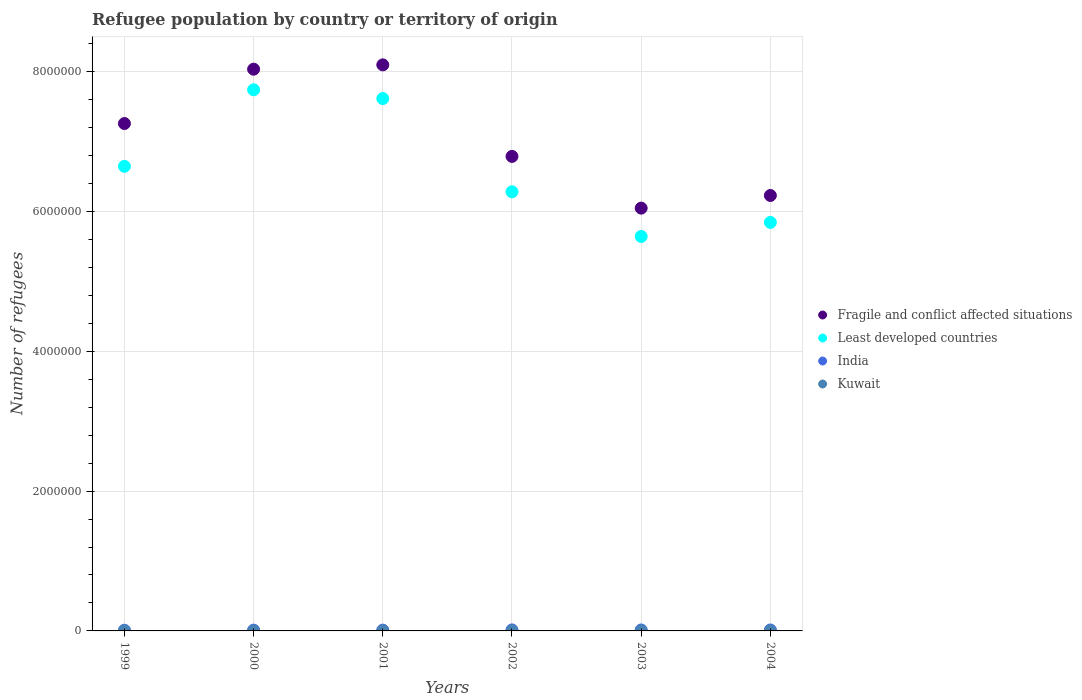How many different coloured dotlines are there?
Offer a terse response. 4. What is the number of refugees in Least developed countries in 2000?
Your answer should be compact. 7.74e+06. Across all years, what is the maximum number of refugees in Fragile and conflict affected situations?
Ensure brevity in your answer.  8.10e+06. Across all years, what is the minimum number of refugees in India?
Your answer should be very brief. 9845. In which year was the number of refugees in India maximum?
Give a very brief answer. 2002. In which year was the number of refugees in Fragile and conflict affected situations minimum?
Your answer should be compact. 2003. What is the total number of refugees in Least developed countries in the graph?
Your response must be concise. 3.98e+07. What is the difference between the number of refugees in India in 1999 and that in 2003?
Make the answer very short. -3861. What is the difference between the number of refugees in Kuwait in 2002 and the number of refugees in Fragile and conflict affected situations in 2003?
Give a very brief answer. -6.05e+06. What is the average number of refugees in Least developed countries per year?
Make the answer very short. 6.63e+06. In the year 2000, what is the difference between the number of refugees in India and number of refugees in Least developed countries?
Give a very brief answer. -7.73e+06. In how many years, is the number of refugees in Least developed countries greater than 3200000?
Ensure brevity in your answer.  6. What is the ratio of the number of refugees in Kuwait in 1999 to that in 2002?
Keep it short and to the point. 1.4. Is the difference between the number of refugees in India in 1999 and 2001 greater than the difference between the number of refugees in Least developed countries in 1999 and 2001?
Keep it short and to the point. Yes. What is the difference between the highest and the second highest number of refugees in Kuwait?
Provide a succinct answer. 283. What is the difference between the highest and the lowest number of refugees in Least developed countries?
Your response must be concise. 2.10e+06. Is the sum of the number of refugees in Fragile and conflict affected situations in 2000 and 2003 greater than the maximum number of refugees in Least developed countries across all years?
Offer a very short reply. Yes. Is it the case that in every year, the sum of the number of refugees in Kuwait and number of refugees in Fragile and conflict affected situations  is greater than the sum of number of refugees in Least developed countries and number of refugees in India?
Offer a very short reply. No. Is it the case that in every year, the sum of the number of refugees in Fragile and conflict affected situations and number of refugees in Kuwait  is greater than the number of refugees in India?
Your answer should be compact. Yes. Does the number of refugees in Kuwait monotonically increase over the years?
Offer a very short reply. No. Is the number of refugees in Kuwait strictly greater than the number of refugees in Fragile and conflict affected situations over the years?
Your answer should be compact. No. What is the difference between two consecutive major ticks on the Y-axis?
Your response must be concise. 2.00e+06. Are the values on the major ticks of Y-axis written in scientific E-notation?
Your answer should be compact. No. Where does the legend appear in the graph?
Offer a terse response. Center right. What is the title of the graph?
Your answer should be very brief. Refugee population by country or territory of origin. What is the label or title of the Y-axis?
Make the answer very short. Number of refugees. What is the Number of refugees of Fragile and conflict affected situations in 1999?
Offer a very short reply. 7.26e+06. What is the Number of refugees of Least developed countries in 1999?
Your answer should be compact. 6.64e+06. What is the Number of refugees in India in 1999?
Your answer should be very brief. 9845. What is the Number of refugees of Kuwait in 1999?
Ensure brevity in your answer.  992. What is the Number of refugees of Fragile and conflict affected situations in 2000?
Give a very brief answer. 8.03e+06. What is the Number of refugees of Least developed countries in 2000?
Provide a succinct answer. 7.74e+06. What is the Number of refugees in India in 2000?
Offer a very short reply. 1.14e+04. What is the Number of refugees in Kuwait in 2000?
Keep it short and to the point. 692. What is the Number of refugees in Fragile and conflict affected situations in 2001?
Provide a short and direct response. 8.10e+06. What is the Number of refugees of Least developed countries in 2001?
Provide a short and direct response. 7.61e+06. What is the Number of refugees of India in 2001?
Your answer should be compact. 1.16e+04. What is the Number of refugees of Kuwait in 2001?
Ensure brevity in your answer.  701. What is the Number of refugees in Fragile and conflict affected situations in 2002?
Your answer should be compact. 6.79e+06. What is the Number of refugees of Least developed countries in 2002?
Your response must be concise. 6.28e+06. What is the Number of refugees in India in 2002?
Provide a short and direct response. 1.43e+04. What is the Number of refugees of Kuwait in 2002?
Your response must be concise. 709. What is the Number of refugees in Fragile and conflict affected situations in 2003?
Offer a terse response. 6.05e+06. What is the Number of refugees of Least developed countries in 2003?
Make the answer very short. 5.64e+06. What is the Number of refugees in India in 2003?
Keep it short and to the point. 1.37e+04. What is the Number of refugees of Kuwait in 2003?
Offer a very short reply. 616. What is the Number of refugees in Fragile and conflict affected situations in 2004?
Offer a terse response. 6.23e+06. What is the Number of refugees in Least developed countries in 2004?
Make the answer very short. 5.84e+06. What is the Number of refugees in India in 2004?
Provide a succinct answer. 1.33e+04. What is the Number of refugees of Kuwait in 2004?
Offer a very short reply. 398. Across all years, what is the maximum Number of refugees of Fragile and conflict affected situations?
Your answer should be compact. 8.10e+06. Across all years, what is the maximum Number of refugees in Least developed countries?
Keep it short and to the point. 7.74e+06. Across all years, what is the maximum Number of refugees in India?
Keep it short and to the point. 1.43e+04. Across all years, what is the maximum Number of refugees in Kuwait?
Provide a succinct answer. 992. Across all years, what is the minimum Number of refugees of Fragile and conflict affected situations?
Provide a succinct answer. 6.05e+06. Across all years, what is the minimum Number of refugees in Least developed countries?
Offer a terse response. 5.64e+06. Across all years, what is the minimum Number of refugees of India?
Your response must be concise. 9845. Across all years, what is the minimum Number of refugees in Kuwait?
Give a very brief answer. 398. What is the total Number of refugees of Fragile and conflict affected situations in the graph?
Make the answer very short. 4.24e+07. What is the total Number of refugees in Least developed countries in the graph?
Keep it short and to the point. 3.98e+07. What is the total Number of refugees of India in the graph?
Ensure brevity in your answer.  7.42e+04. What is the total Number of refugees in Kuwait in the graph?
Provide a succinct answer. 4108. What is the difference between the Number of refugees in Fragile and conflict affected situations in 1999 and that in 2000?
Offer a terse response. -7.77e+05. What is the difference between the Number of refugees of Least developed countries in 1999 and that in 2000?
Your response must be concise. -1.09e+06. What is the difference between the Number of refugees of India in 1999 and that in 2000?
Provide a short and direct response. -1554. What is the difference between the Number of refugees of Kuwait in 1999 and that in 2000?
Give a very brief answer. 300. What is the difference between the Number of refugees of Fragile and conflict affected situations in 1999 and that in 2001?
Keep it short and to the point. -8.39e+05. What is the difference between the Number of refugees in Least developed countries in 1999 and that in 2001?
Your response must be concise. -9.69e+05. What is the difference between the Number of refugees in India in 1999 and that in 2001?
Ensure brevity in your answer.  -1726. What is the difference between the Number of refugees in Kuwait in 1999 and that in 2001?
Give a very brief answer. 291. What is the difference between the Number of refugees in Fragile and conflict affected situations in 1999 and that in 2002?
Offer a terse response. 4.70e+05. What is the difference between the Number of refugees in Least developed countries in 1999 and that in 2002?
Offer a terse response. 3.64e+05. What is the difference between the Number of refugees in India in 1999 and that in 2002?
Provide a short and direct response. -4504. What is the difference between the Number of refugees of Kuwait in 1999 and that in 2002?
Ensure brevity in your answer.  283. What is the difference between the Number of refugees in Fragile and conflict affected situations in 1999 and that in 2003?
Offer a terse response. 1.21e+06. What is the difference between the Number of refugees in Least developed countries in 1999 and that in 2003?
Provide a succinct answer. 1.00e+06. What is the difference between the Number of refugees of India in 1999 and that in 2003?
Your response must be concise. -3861. What is the difference between the Number of refugees in Kuwait in 1999 and that in 2003?
Offer a very short reply. 376. What is the difference between the Number of refugees of Fragile and conflict affected situations in 1999 and that in 2004?
Ensure brevity in your answer.  1.03e+06. What is the difference between the Number of refugees in Least developed countries in 1999 and that in 2004?
Offer a terse response. 8.02e+05. What is the difference between the Number of refugees in India in 1999 and that in 2004?
Make the answer very short. -3500. What is the difference between the Number of refugees in Kuwait in 1999 and that in 2004?
Give a very brief answer. 594. What is the difference between the Number of refugees in Fragile and conflict affected situations in 2000 and that in 2001?
Provide a succinct answer. -6.18e+04. What is the difference between the Number of refugees in Least developed countries in 2000 and that in 2001?
Give a very brief answer. 1.26e+05. What is the difference between the Number of refugees in India in 2000 and that in 2001?
Offer a terse response. -172. What is the difference between the Number of refugees of Kuwait in 2000 and that in 2001?
Ensure brevity in your answer.  -9. What is the difference between the Number of refugees in Fragile and conflict affected situations in 2000 and that in 2002?
Your answer should be compact. 1.25e+06. What is the difference between the Number of refugees in Least developed countries in 2000 and that in 2002?
Give a very brief answer. 1.46e+06. What is the difference between the Number of refugees of India in 2000 and that in 2002?
Make the answer very short. -2950. What is the difference between the Number of refugees of Kuwait in 2000 and that in 2002?
Make the answer very short. -17. What is the difference between the Number of refugees of Fragile and conflict affected situations in 2000 and that in 2003?
Ensure brevity in your answer.  1.99e+06. What is the difference between the Number of refugees in Least developed countries in 2000 and that in 2003?
Ensure brevity in your answer.  2.10e+06. What is the difference between the Number of refugees of India in 2000 and that in 2003?
Give a very brief answer. -2307. What is the difference between the Number of refugees in Fragile and conflict affected situations in 2000 and that in 2004?
Provide a short and direct response. 1.81e+06. What is the difference between the Number of refugees of Least developed countries in 2000 and that in 2004?
Ensure brevity in your answer.  1.90e+06. What is the difference between the Number of refugees in India in 2000 and that in 2004?
Ensure brevity in your answer.  -1946. What is the difference between the Number of refugees of Kuwait in 2000 and that in 2004?
Ensure brevity in your answer.  294. What is the difference between the Number of refugees of Fragile and conflict affected situations in 2001 and that in 2002?
Offer a very short reply. 1.31e+06. What is the difference between the Number of refugees of Least developed countries in 2001 and that in 2002?
Offer a terse response. 1.33e+06. What is the difference between the Number of refugees of India in 2001 and that in 2002?
Keep it short and to the point. -2778. What is the difference between the Number of refugees in Kuwait in 2001 and that in 2002?
Your answer should be compact. -8. What is the difference between the Number of refugees in Fragile and conflict affected situations in 2001 and that in 2003?
Provide a succinct answer. 2.05e+06. What is the difference between the Number of refugees of Least developed countries in 2001 and that in 2003?
Provide a succinct answer. 1.97e+06. What is the difference between the Number of refugees in India in 2001 and that in 2003?
Provide a short and direct response. -2135. What is the difference between the Number of refugees in Kuwait in 2001 and that in 2003?
Provide a succinct answer. 85. What is the difference between the Number of refugees of Fragile and conflict affected situations in 2001 and that in 2004?
Offer a terse response. 1.87e+06. What is the difference between the Number of refugees in Least developed countries in 2001 and that in 2004?
Your response must be concise. 1.77e+06. What is the difference between the Number of refugees of India in 2001 and that in 2004?
Provide a short and direct response. -1774. What is the difference between the Number of refugees in Kuwait in 2001 and that in 2004?
Your response must be concise. 303. What is the difference between the Number of refugees of Fragile and conflict affected situations in 2002 and that in 2003?
Ensure brevity in your answer.  7.40e+05. What is the difference between the Number of refugees in Least developed countries in 2002 and that in 2003?
Keep it short and to the point. 6.39e+05. What is the difference between the Number of refugees of India in 2002 and that in 2003?
Offer a terse response. 643. What is the difference between the Number of refugees of Kuwait in 2002 and that in 2003?
Give a very brief answer. 93. What is the difference between the Number of refugees in Fragile and conflict affected situations in 2002 and that in 2004?
Your answer should be compact. 5.59e+05. What is the difference between the Number of refugees in Least developed countries in 2002 and that in 2004?
Provide a succinct answer. 4.38e+05. What is the difference between the Number of refugees of India in 2002 and that in 2004?
Your response must be concise. 1004. What is the difference between the Number of refugees in Kuwait in 2002 and that in 2004?
Your response must be concise. 311. What is the difference between the Number of refugees in Fragile and conflict affected situations in 2003 and that in 2004?
Offer a very short reply. -1.81e+05. What is the difference between the Number of refugees of Least developed countries in 2003 and that in 2004?
Give a very brief answer. -2.01e+05. What is the difference between the Number of refugees in India in 2003 and that in 2004?
Provide a short and direct response. 361. What is the difference between the Number of refugees in Kuwait in 2003 and that in 2004?
Your answer should be very brief. 218. What is the difference between the Number of refugees of Fragile and conflict affected situations in 1999 and the Number of refugees of Least developed countries in 2000?
Keep it short and to the point. -4.83e+05. What is the difference between the Number of refugees of Fragile and conflict affected situations in 1999 and the Number of refugees of India in 2000?
Provide a short and direct response. 7.24e+06. What is the difference between the Number of refugees in Fragile and conflict affected situations in 1999 and the Number of refugees in Kuwait in 2000?
Make the answer very short. 7.26e+06. What is the difference between the Number of refugees in Least developed countries in 1999 and the Number of refugees in India in 2000?
Your answer should be compact. 6.63e+06. What is the difference between the Number of refugees of Least developed countries in 1999 and the Number of refugees of Kuwait in 2000?
Keep it short and to the point. 6.64e+06. What is the difference between the Number of refugees of India in 1999 and the Number of refugees of Kuwait in 2000?
Provide a short and direct response. 9153. What is the difference between the Number of refugees in Fragile and conflict affected situations in 1999 and the Number of refugees in Least developed countries in 2001?
Provide a short and direct response. -3.57e+05. What is the difference between the Number of refugees in Fragile and conflict affected situations in 1999 and the Number of refugees in India in 2001?
Keep it short and to the point. 7.24e+06. What is the difference between the Number of refugees of Fragile and conflict affected situations in 1999 and the Number of refugees of Kuwait in 2001?
Give a very brief answer. 7.26e+06. What is the difference between the Number of refugees in Least developed countries in 1999 and the Number of refugees in India in 2001?
Your response must be concise. 6.63e+06. What is the difference between the Number of refugees in Least developed countries in 1999 and the Number of refugees in Kuwait in 2001?
Provide a short and direct response. 6.64e+06. What is the difference between the Number of refugees in India in 1999 and the Number of refugees in Kuwait in 2001?
Ensure brevity in your answer.  9144. What is the difference between the Number of refugees of Fragile and conflict affected situations in 1999 and the Number of refugees of Least developed countries in 2002?
Provide a succinct answer. 9.76e+05. What is the difference between the Number of refugees of Fragile and conflict affected situations in 1999 and the Number of refugees of India in 2002?
Your answer should be compact. 7.24e+06. What is the difference between the Number of refugees of Fragile and conflict affected situations in 1999 and the Number of refugees of Kuwait in 2002?
Offer a terse response. 7.26e+06. What is the difference between the Number of refugees of Least developed countries in 1999 and the Number of refugees of India in 2002?
Your answer should be compact. 6.63e+06. What is the difference between the Number of refugees in Least developed countries in 1999 and the Number of refugees in Kuwait in 2002?
Make the answer very short. 6.64e+06. What is the difference between the Number of refugees of India in 1999 and the Number of refugees of Kuwait in 2002?
Keep it short and to the point. 9136. What is the difference between the Number of refugees of Fragile and conflict affected situations in 1999 and the Number of refugees of Least developed countries in 2003?
Keep it short and to the point. 1.62e+06. What is the difference between the Number of refugees in Fragile and conflict affected situations in 1999 and the Number of refugees in India in 2003?
Your answer should be compact. 7.24e+06. What is the difference between the Number of refugees in Fragile and conflict affected situations in 1999 and the Number of refugees in Kuwait in 2003?
Provide a short and direct response. 7.26e+06. What is the difference between the Number of refugees of Least developed countries in 1999 and the Number of refugees of India in 2003?
Keep it short and to the point. 6.63e+06. What is the difference between the Number of refugees in Least developed countries in 1999 and the Number of refugees in Kuwait in 2003?
Keep it short and to the point. 6.64e+06. What is the difference between the Number of refugees in India in 1999 and the Number of refugees in Kuwait in 2003?
Your response must be concise. 9229. What is the difference between the Number of refugees of Fragile and conflict affected situations in 1999 and the Number of refugees of Least developed countries in 2004?
Make the answer very short. 1.41e+06. What is the difference between the Number of refugees in Fragile and conflict affected situations in 1999 and the Number of refugees in India in 2004?
Give a very brief answer. 7.24e+06. What is the difference between the Number of refugees of Fragile and conflict affected situations in 1999 and the Number of refugees of Kuwait in 2004?
Your answer should be very brief. 7.26e+06. What is the difference between the Number of refugees in Least developed countries in 1999 and the Number of refugees in India in 2004?
Offer a terse response. 6.63e+06. What is the difference between the Number of refugees of Least developed countries in 1999 and the Number of refugees of Kuwait in 2004?
Your response must be concise. 6.64e+06. What is the difference between the Number of refugees of India in 1999 and the Number of refugees of Kuwait in 2004?
Your answer should be compact. 9447. What is the difference between the Number of refugees of Fragile and conflict affected situations in 2000 and the Number of refugees of Least developed countries in 2001?
Make the answer very short. 4.20e+05. What is the difference between the Number of refugees of Fragile and conflict affected situations in 2000 and the Number of refugees of India in 2001?
Make the answer very short. 8.02e+06. What is the difference between the Number of refugees in Fragile and conflict affected situations in 2000 and the Number of refugees in Kuwait in 2001?
Offer a terse response. 8.03e+06. What is the difference between the Number of refugees in Least developed countries in 2000 and the Number of refugees in India in 2001?
Offer a very short reply. 7.73e+06. What is the difference between the Number of refugees in Least developed countries in 2000 and the Number of refugees in Kuwait in 2001?
Make the answer very short. 7.74e+06. What is the difference between the Number of refugees of India in 2000 and the Number of refugees of Kuwait in 2001?
Give a very brief answer. 1.07e+04. What is the difference between the Number of refugees of Fragile and conflict affected situations in 2000 and the Number of refugees of Least developed countries in 2002?
Give a very brief answer. 1.75e+06. What is the difference between the Number of refugees of Fragile and conflict affected situations in 2000 and the Number of refugees of India in 2002?
Keep it short and to the point. 8.02e+06. What is the difference between the Number of refugees of Fragile and conflict affected situations in 2000 and the Number of refugees of Kuwait in 2002?
Give a very brief answer. 8.03e+06. What is the difference between the Number of refugees of Least developed countries in 2000 and the Number of refugees of India in 2002?
Your response must be concise. 7.72e+06. What is the difference between the Number of refugees of Least developed countries in 2000 and the Number of refugees of Kuwait in 2002?
Ensure brevity in your answer.  7.74e+06. What is the difference between the Number of refugees of India in 2000 and the Number of refugees of Kuwait in 2002?
Your response must be concise. 1.07e+04. What is the difference between the Number of refugees of Fragile and conflict affected situations in 2000 and the Number of refugees of Least developed countries in 2003?
Offer a terse response. 2.39e+06. What is the difference between the Number of refugees of Fragile and conflict affected situations in 2000 and the Number of refugees of India in 2003?
Provide a short and direct response. 8.02e+06. What is the difference between the Number of refugees in Fragile and conflict affected situations in 2000 and the Number of refugees in Kuwait in 2003?
Your response must be concise. 8.03e+06. What is the difference between the Number of refugees in Least developed countries in 2000 and the Number of refugees in India in 2003?
Ensure brevity in your answer.  7.73e+06. What is the difference between the Number of refugees of Least developed countries in 2000 and the Number of refugees of Kuwait in 2003?
Your response must be concise. 7.74e+06. What is the difference between the Number of refugees in India in 2000 and the Number of refugees in Kuwait in 2003?
Your response must be concise. 1.08e+04. What is the difference between the Number of refugees in Fragile and conflict affected situations in 2000 and the Number of refugees in Least developed countries in 2004?
Provide a succinct answer. 2.19e+06. What is the difference between the Number of refugees in Fragile and conflict affected situations in 2000 and the Number of refugees in India in 2004?
Provide a succinct answer. 8.02e+06. What is the difference between the Number of refugees of Fragile and conflict affected situations in 2000 and the Number of refugees of Kuwait in 2004?
Your answer should be very brief. 8.03e+06. What is the difference between the Number of refugees in Least developed countries in 2000 and the Number of refugees in India in 2004?
Your answer should be very brief. 7.73e+06. What is the difference between the Number of refugees of Least developed countries in 2000 and the Number of refugees of Kuwait in 2004?
Your answer should be compact. 7.74e+06. What is the difference between the Number of refugees in India in 2000 and the Number of refugees in Kuwait in 2004?
Offer a terse response. 1.10e+04. What is the difference between the Number of refugees of Fragile and conflict affected situations in 2001 and the Number of refugees of Least developed countries in 2002?
Your response must be concise. 1.82e+06. What is the difference between the Number of refugees in Fragile and conflict affected situations in 2001 and the Number of refugees in India in 2002?
Ensure brevity in your answer.  8.08e+06. What is the difference between the Number of refugees in Fragile and conflict affected situations in 2001 and the Number of refugees in Kuwait in 2002?
Your response must be concise. 8.09e+06. What is the difference between the Number of refugees of Least developed countries in 2001 and the Number of refugees of India in 2002?
Keep it short and to the point. 7.60e+06. What is the difference between the Number of refugees of Least developed countries in 2001 and the Number of refugees of Kuwait in 2002?
Your response must be concise. 7.61e+06. What is the difference between the Number of refugees of India in 2001 and the Number of refugees of Kuwait in 2002?
Provide a short and direct response. 1.09e+04. What is the difference between the Number of refugees in Fragile and conflict affected situations in 2001 and the Number of refugees in Least developed countries in 2003?
Offer a terse response. 2.45e+06. What is the difference between the Number of refugees of Fragile and conflict affected situations in 2001 and the Number of refugees of India in 2003?
Keep it short and to the point. 8.08e+06. What is the difference between the Number of refugees of Fragile and conflict affected situations in 2001 and the Number of refugees of Kuwait in 2003?
Provide a short and direct response. 8.09e+06. What is the difference between the Number of refugees of Least developed countries in 2001 and the Number of refugees of India in 2003?
Keep it short and to the point. 7.60e+06. What is the difference between the Number of refugees of Least developed countries in 2001 and the Number of refugees of Kuwait in 2003?
Your response must be concise. 7.61e+06. What is the difference between the Number of refugees in India in 2001 and the Number of refugees in Kuwait in 2003?
Offer a terse response. 1.10e+04. What is the difference between the Number of refugees in Fragile and conflict affected situations in 2001 and the Number of refugees in Least developed countries in 2004?
Ensure brevity in your answer.  2.25e+06. What is the difference between the Number of refugees in Fragile and conflict affected situations in 2001 and the Number of refugees in India in 2004?
Give a very brief answer. 8.08e+06. What is the difference between the Number of refugees in Fragile and conflict affected situations in 2001 and the Number of refugees in Kuwait in 2004?
Ensure brevity in your answer.  8.09e+06. What is the difference between the Number of refugees of Least developed countries in 2001 and the Number of refugees of India in 2004?
Offer a very short reply. 7.60e+06. What is the difference between the Number of refugees in Least developed countries in 2001 and the Number of refugees in Kuwait in 2004?
Offer a terse response. 7.61e+06. What is the difference between the Number of refugees in India in 2001 and the Number of refugees in Kuwait in 2004?
Give a very brief answer. 1.12e+04. What is the difference between the Number of refugees of Fragile and conflict affected situations in 2002 and the Number of refugees of Least developed countries in 2003?
Ensure brevity in your answer.  1.15e+06. What is the difference between the Number of refugees of Fragile and conflict affected situations in 2002 and the Number of refugees of India in 2003?
Your answer should be very brief. 6.77e+06. What is the difference between the Number of refugees of Fragile and conflict affected situations in 2002 and the Number of refugees of Kuwait in 2003?
Provide a short and direct response. 6.79e+06. What is the difference between the Number of refugees in Least developed countries in 2002 and the Number of refugees in India in 2003?
Your answer should be very brief. 6.27e+06. What is the difference between the Number of refugees in Least developed countries in 2002 and the Number of refugees in Kuwait in 2003?
Your answer should be very brief. 6.28e+06. What is the difference between the Number of refugees in India in 2002 and the Number of refugees in Kuwait in 2003?
Provide a short and direct response. 1.37e+04. What is the difference between the Number of refugees of Fragile and conflict affected situations in 2002 and the Number of refugees of Least developed countries in 2004?
Offer a very short reply. 9.44e+05. What is the difference between the Number of refugees in Fragile and conflict affected situations in 2002 and the Number of refugees in India in 2004?
Ensure brevity in your answer.  6.77e+06. What is the difference between the Number of refugees in Fragile and conflict affected situations in 2002 and the Number of refugees in Kuwait in 2004?
Provide a succinct answer. 6.79e+06. What is the difference between the Number of refugees of Least developed countries in 2002 and the Number of refugees of India in 2004?
Your response must be concise. 6.27e+06. What is the difference between the Number of refugees in Least developed countries in 2002 and the Number of refugees in Kuwait in 2004?
Your answer should be very brief. 6.28e+06. What is the difference between the Number of refugees of India in 2002 and the Number of refugees of Kuwait in 2004?
Provide a succinct answer. 1.40e+04. What is the difference between the Number of refugees of Fragile and conflict affected situations in 2003 and the Number of refugees of Least developed countries in 2004?
Your answer should be very brief. 2.04e+05. What is the difference between the Number of refugees of Fragile and conflict affected situations in 2003 and the Number of refugees of India in 2004?
Your response must be concise. 6.03e+06. What is the difference between the Number of refugees in Fragile and conflict affected situations in 2003 and the Number of refugees in Kuwait in 2004?
Keep it short and to the point. 6.05e+06. What is the difference between the Number of refugees of Least developed countries in 2003 and the Number of refugees of India in 2004?
Provide a succinct answer. 5.63e+06. What is the difference between the Number of refugees in Least developed countries in 2003 and the Number of refugees in Kuwait in 2004?
Your answer should be compact. 5.64e+06. What is the difference between the Number of refugees in India in 2003 and the Number of refugees in Kuwait in 2004?
Give a very brief answer. 1.33e+04. What is the average Number of refugees in Fragile and conflict affected situations per year?
Your answer should be compact. 7.07e+06. What is the average Number of refugees in Least developed countries per year?
Offer a terse response. 6.63e+06. What is the average Number of refugees in India per year?
Make the answer very short. 1.24e+04. What is the average Number of refugees of Kuwait per year?
Provide a succinct answer. 684.67. In the year 1999, what is the difference between the Number of refugees in Fragile and conflict affected situations and Number of refugees in Least developed countries?
Your answer should be very brief. 6.12e+05. In the year 1999, what is the difference between the Number of refugees of Fragile and conflict affected situations and Number of refugees of India?
Offer a terse response. 7.25e+06. In the year 1999, what is the difference between the Number of refugees in Fragile and conflict affected situations and Number of refugees in Kuwait?
Keep it short and to the point. 7.26e+06. In the year 1999, what is the difference between the Number of refugees of Least developed countries and Number of refugees of India?
Provide a short and direct response. 6.63e+06. In the year 1999, what is the difference between the Number of refugees in Least developed countries and Number of refugees in Kuwait?
Keep it short and to the point. 6.64e+06. In the year 1999, what is the difference between the Number of refugees of India and Number of refugees of Kuwait?
Provide a succinct answer. 8853. In the year 2000, what is the difference between the Number of refugees of Fragile and conflict affected situations and Number of refugees of Least developed countries?
Provide a short and direct response. 2.94e+05. In the year 2000, what is the difference between the Number of refugees in Fragile and conflict affected situations and Number of refugees in India?
Provide a succinct answer. 8.02e+06. In the year 2000, what is the difference between the Number of refugees in Fragile and conflict affected situations and Number of refugees in Kuwait?
Your answer should be compact. 8.03e+06. In the year 2000, what is the difference between the Number of refugees of Least developed countries and Number of refugees of India?
Keep it short and to the point. 7.73e+06. In the year 2000, what is the difference between the Number of refugees in Least developed countries and Number of refugees in Kuwait?
Your response must be concise. 7.74e+06. In the year 2000, what is the difference between the Number of refugees in India and Number of refugees in Kuwait?
Your response must be concise. 1.07e+04. In the year 2001, what is the difference between the Number of refugees in Fragile and conflict affected situations and Number of refugees in Least developed countries?
Your response must be concise. 4.82e+05. In the year 2001, what is the difference between the Number of refugees in Fragile and conflict affected situations and Number of refugees in India?
Your response must be concise. 8.08e+06. In the year 2001, what is the difference between the Number of refugees of Fragile and conflict affected situations and Number of refugees of Kuwait?
Your answer should be compact. 8.09e+06. In the year 2001, what is the difference between the Number of refugees in Least developed countries and Number of refugees in India?
Keep it short and to the point. 7.60e+06. In the year 2001, what is the difference between the Number of refugees in Least developed countries and Number of refugees in Kuwait?
Make the answer very short. 7.61e+06. In the year 2001, what is the difference between the Number of refugees of India and Number of refugees of Kuwait?
Keep it short and to the point. 1.09e+04. In the year 2002, what is the difference between the Number of refugees in Fragile and conflict affected situations and Number of refugees in Least developed countries?
Provide a short and direct response. 5.06e+05. In the year 2002, what is the difference between the Number of refugees of Fragile and conflict affected situations and Number of refugees of India?
Offer a very short reply. 6.77e+06. In the year 2002, what is the difference between the Number of refugees in Fragile and conflict affected situations and Number of refugees in Kuwait?
Ensure brevity in your answer.  6.79e+06. In the year 2002, what is the difference between the Number of refugees in Least developed countries and Number of refugees in India?
Your response must be concise. 6.27e+06. In the year 2002, what is the difference between the Number of refugees of Least developed countries and Number of refugees of Kuwait?
Your response must be concise. 6.28e+06. In the year 2002, what is the difference between the Number of refugees of India and Number of refugees of Kuwait?
Provide a succinct answer. 1.36e+04. In the year 2003, what is the difference between the Number of refugees in Fragile and conflict affected situations and Number of refugees in Least developed countries?
Give a very brief answer. 4.05e+05. In the year 2003, what is the difference between the Number of refugees in Fragile and conflict affected situations and Number of refugees in India?
Your answer should be very brief. 6.03e+06. In the year 2003, what is the difference between the Number of refugees in Fragile and conflict affected situations and Number of refugees in Kuwait?
Give a very brief answer. 6.05e+06. In the year 2003, what is the difference between the Number of refugees in Least developed countries and Number of refugees in India?
Offer a terse response. 5.63e+06. In the year 2003, what is the difference between the Number of refugees of Least developed countries and Number of refugees of Kuwait?
Your answer should be very brief. 5.64e+06. In the year 2003, what is the difference between the Number of refugees in India and Number of refugees in Kuwait?
Provide a short and direct response. 1.31e+04. In the year 2004, what is the difference between the Number of refugees of Fragile and conflict affected situations and Number of refugees of Least developed countries?
Your answer should be compact. 3.85e+05. In the year 2004, what is the difference between the Number of refugees in Fragile and conflict affected situations and Number of refugees in India?
Ensure brevity in your answer.  6.21e+06. In the year 2004, what is the difference between the Number of refugees in Fragile and conflict affected situations and Number of refugees in Kuwait?
Keep it short and to the point. 6.23e+06. In the year 2004, what is the difference between the Number of refugees of Least developed countries and Number of refugees of India?
Provide a short and direct response. 5.83e+06. In the year 2004, what is the difference between the Number of refugees in Least developed countries and Number of refugees in Kuwait?
Ensure brevity in your answer.  5.84e+06. In the year 2004, what is the difference between the Number of refugees in India and Number of refugees in Kuwait?
Your answer should be compact. 1.29e+04. What is the ratio of the Number of refugees of Fragile and conflict affected situations in 1999 to that in 2000?
Provide a succinct answer. 0.9. What is the ratio of the Number of refugees in Least developed countries in 1999 to that in 2000?
Keep it short and to the point. 0.86. What is the ratio of the Number of refugees in India in 1999 to that in 2000?
Keep it short and to the point. 0.86. What is the ratio of the Number of refugees in Kuwait in 1999 to that in 2000?
Keep it short and to the point. 1.43. What is the ratio of the Number of refugees in Fragile and conflict affected situations in 1999 to that in 2001?
Make the answer very short. 0.9. What is the ratio of the Number of refugees in Least developed countries in 1999 to that in 2001?
Offer a very short reply. 0.87. What is the ratio of the Number of refugees in India in 1999 to that in 2001?
Keep it short and to the point. 0.85. What is the ratio of the Number of refugees in Kuwait in 1999 to that in 2001?
Keep it short and to the point. 1.42. What is the ratio of the Number of refugees in Fragile and conflict affected situations in 1999 to that in 2002?
Keep it short and to the point. 1.07. What is the ratio of the Number of refugees in Least developed countries in 1999 to that in 2002?
Your answer should be compact. 1.06. What is the ratio of the Number of refugees of India in 1999 to that in 2002?
Your answer should be compact. 0.69. What is the ratio of the Number of refugees in Kuwait in 1999 to that in 2002?
Keep it short and to the point. 1.4. What is the ratio of the Number of refugees of Fragile and conflict affected situations in 1999 to that in 2003?
Keep it short and to the point. 1.2. What is the ratio of the Number of refugees of Least developed countries in 1999 to that in 2003?
Give a very brief answer. 1.18. What is the ratio of the Number of refugees of India in 1999 to that in 2003?
Your answer should be compact. 0.72. What is the ratio of the Number of refugees of Kuwait in 1999 to that in 2003?
Provide a succinct answer. 1.61. What is the ratio of the Number of refugees in Fragile and conflict affected situations in 1999 to that in 2004?
Provide a succinct answer. 1.17. What is the ratio of the Number of refugees in Least developed countries in 1999 to that in 2004?
Your answer should be very brief. 1.14. What is the ratio of the Number of refugees in India in 1999 to that in 2004?
Your answer should be compact. 0.74. What is the ratio of the Number of refugees in Kuwait in 1999 to that in 2004?
Your answer should be very brief. 2.49. What is the ratio of the Number of refugees in Least developed countries in 2000 to that in 2001?
Give a very brief answer. 1.02. What is the ratio of the Number of refugees of India in 2000 to that in 2001?
Ensure brevity in your answer.  0.99. What is the ratio of the Number of refugees of Kuwait in 2000 to that in 2001?
Keep it short and to the point. 0.99. What is the ratio of the Number of refugees of Fragile and conflict affected situations in 2000 to that in 2002?
Make the answer very short. 1.18. What is the ratio of the Number of refugees of Least developed countries in 2000 to that in 2002?
Ensure brevity in your answer.  1.23. What is the ratio of the Number of refugees of India in 2000 to that in 2002?
Keep it short and to the point. 0.79. What is the ratio of the Number of refugees in Fragile and conflict affected situations in 2000 to that in 2003?
Provide a short and direct response. 1.33. What is the ratio of the Number of refugees in Least developed countries in 2000 to that in 2003?
Your answer should be compact. 1.37. What is the ratio of the Number of refugees in India in 2000 to that in 2003?
Provide a succinct answer. 0.83. What is the ratio of the Number of refugees in Kuwait in 2000 to that in 2003?
Make the answer very short. 1.12. What is the ratio of the Number of refugees in Fragile and conflict affected situations in 2000 to that in 2004?
Give a very brief answer. 1.29. What is the ratio of the Number of refugees of Least developed countries in 2000 to that in 2004?
Offer a terse response. 1.32. What is the ratio of the Number of refugees in India in 2000 to that in 2004?
Offer a terse response. 0.85. What is the ratio of the Number of refugees of Kuwait in 2000 to that in 2004?
Ensure brevity in your answer.  1.74. What is the ratio of the Number of refugees of Fragile and conflict affected situations in 2001 to that in 2002?
Offer a very short reply. 1.19. What is the ratio of the Number of refugees in Least developed countries in 2001 to that in 2002?
Ensure brevity in your answer.  1.21. What is the ratio of the Number of refugees in India in 2001 to that in 2002?
Offer a very short reply. 0.81. What is the ratio of the Number of refugees in Kuwait in 2001 to that in 2002?
Give a very brief answer. 0.99. What is the ratio of the Number of refugees of Fragile and conflict affected situations in 2001 to that in 2003?
Ensure brevity in your answer.  1.34. What is the ratio of the Number of refugees of Least developed countries in 2001 to that in 2003?
Keep it short and to the point. 1.35. What is the ratio of the Number of refugees in India in 2001 to that in 2003?
Your response must be concise. 0.84. What is the ratio of the Number of refugees in Kuwait in 2001 to that in 2003?
Your answer should be very brief. 1.14. What is the ratio of the Number of refugees in Fragile and conflict affected situations in 2001 to that in 2004?
Your answer should be very brief. 1.3. What is the ratio of the Number of refugees of Least developed countries in 2001 to that in 2004?
Your answer should be compact. 1.3. What is the ratio of the Number of refugees in India in 2001 to that in 2004?
Offer a very short reply. 0.87. What is the ratio of the Number of refugees in Kuwait in 2001 to that in 2004?
Your response must be concise. 1.76. What is the ratio of the Number of refugees of Fragile and conflict affected situations in 2002 to that in 2003?
Ensure brevity in your answer.  1.12. What is the ratio of the Number of refugees in Least developed countries in 2002 to that in 2003?
Make the answer very short. 1.11. What is the ratio of the Number of refugees of India in 2002 to that in 2003?
Offer a very short reply. 1.05. What is the ratio of the Number of refugees in Kuwait in 2002 to that in 2003?
Keep it short and to the point. 1.15. What is the ratio of the Number of refugees in Fragile and conflict affected situations in 2002 to that in 2004?
Your answer should be compact. 1.09. What is the ratio of the Number of refugees in Least developed countries in 2002 to that in 2004?
Offer a terse response. 1.07. What is the ratio of the Number of refugees of India in 2002 to that in 2004?
Keep it short and to the point. 1.08. What is the ratio of the Number of refugees in Kuwait in 2002 to that in 2004?
Your answer should be very brief. 1.78. What is the ratio of the Number of refugees in Fragile and conflict affected situations in 2003 to that in 2004?
Make the answer very short. 0.97. What is the ratio of the Number of refugees in Least developed countries in 2003 to that in 2004?
Give a very brief answer. 0.97. What is the ratio of the Number of refugees in India in 2003 to that in 2004?
Ensure brevity in your answer.  1.03. What is the ratio of the Number of refugees in Kuwait in 2003 to that in 2004?
Your response must be concise. 1.55. What is the difference between the highest and the second highest Number of refugees in Fragile and conflict affected situations?
Provide a short and direct response. 6.18e+04. What is the difference between the highest and the second highest Number of refugees in Least developed countries?
Your response must be concise. 1.26e+05. What is the difference between the highest and the second highest Number of refugees of India?
Offer a terse response. 643. What is the difference between the highest and the second highest Number of refugees of Kuwait?
Your answer should be compact. 283. What is the difference between the highest and the lowest Number of refugees of Fragile and conflict affected situations?
Provide a succinct answer. 2.05e+06. What is the difference between the highest and the lowest Number of refugees in Least developed countries?
Ensure brevity in your answer.  2.10e+06. What is the difference between the highest and the lowest Number of refugees in India?
Provide a succinct answer. 4504. What is the difference between the highest and the lowest Number of refugees of Kuwait?
Make the answer very short. 594. 